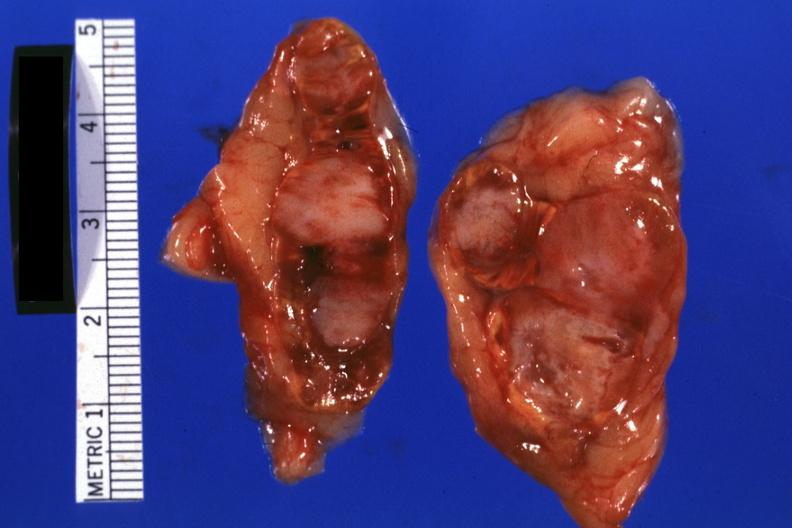what is present?
Answer the question using a single word or phrase. Adrenal 